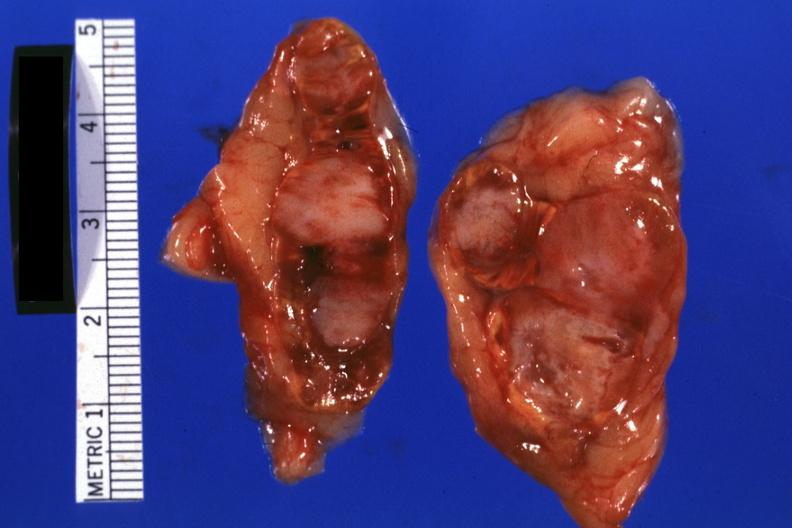what is present?
Answer the question using a single word or phrase. Adrenal 